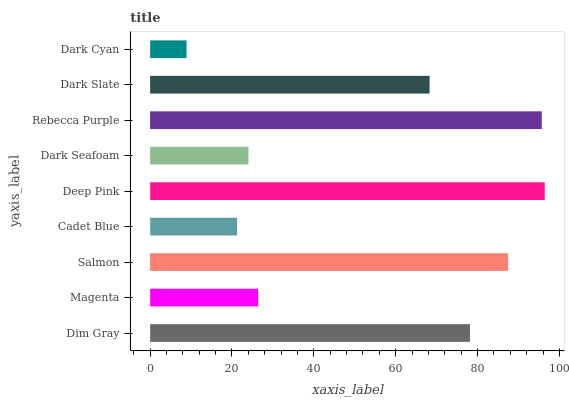Is Dark Cyan the minimum?
Answer yes or no. Yes. Is Deep Pink the maximum?
Answer yes or no. Yes. Is Magenta the minimum?
Answer yes or no. No. Is Magenta the maximum?
Answer yes or no. No. Is Dim Gray greater than Magenta?
Answer yes or no. Yes. Is Magenta less than Dim Gray?
Answer yes or no. Yes. Is Magenta greater than Dim Gray?
Answer yes or no. No. Is Dim Gray less than Magenta?
Answer yes or no. No. Is Dark Slate the high median?
Answer yes or no. Yes. Is Dark Slate the low median?
Answer yes or no. Yes. Is Rebecca Purple the high median?
Answer yes or no. No. Is Dark Seafoam the low median?
Answer yes or no. No. 